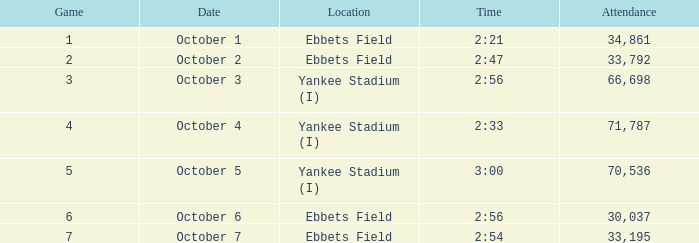Yankee stadium (i), and a time of 3:00 has what attendance for this location? 70536.0. 